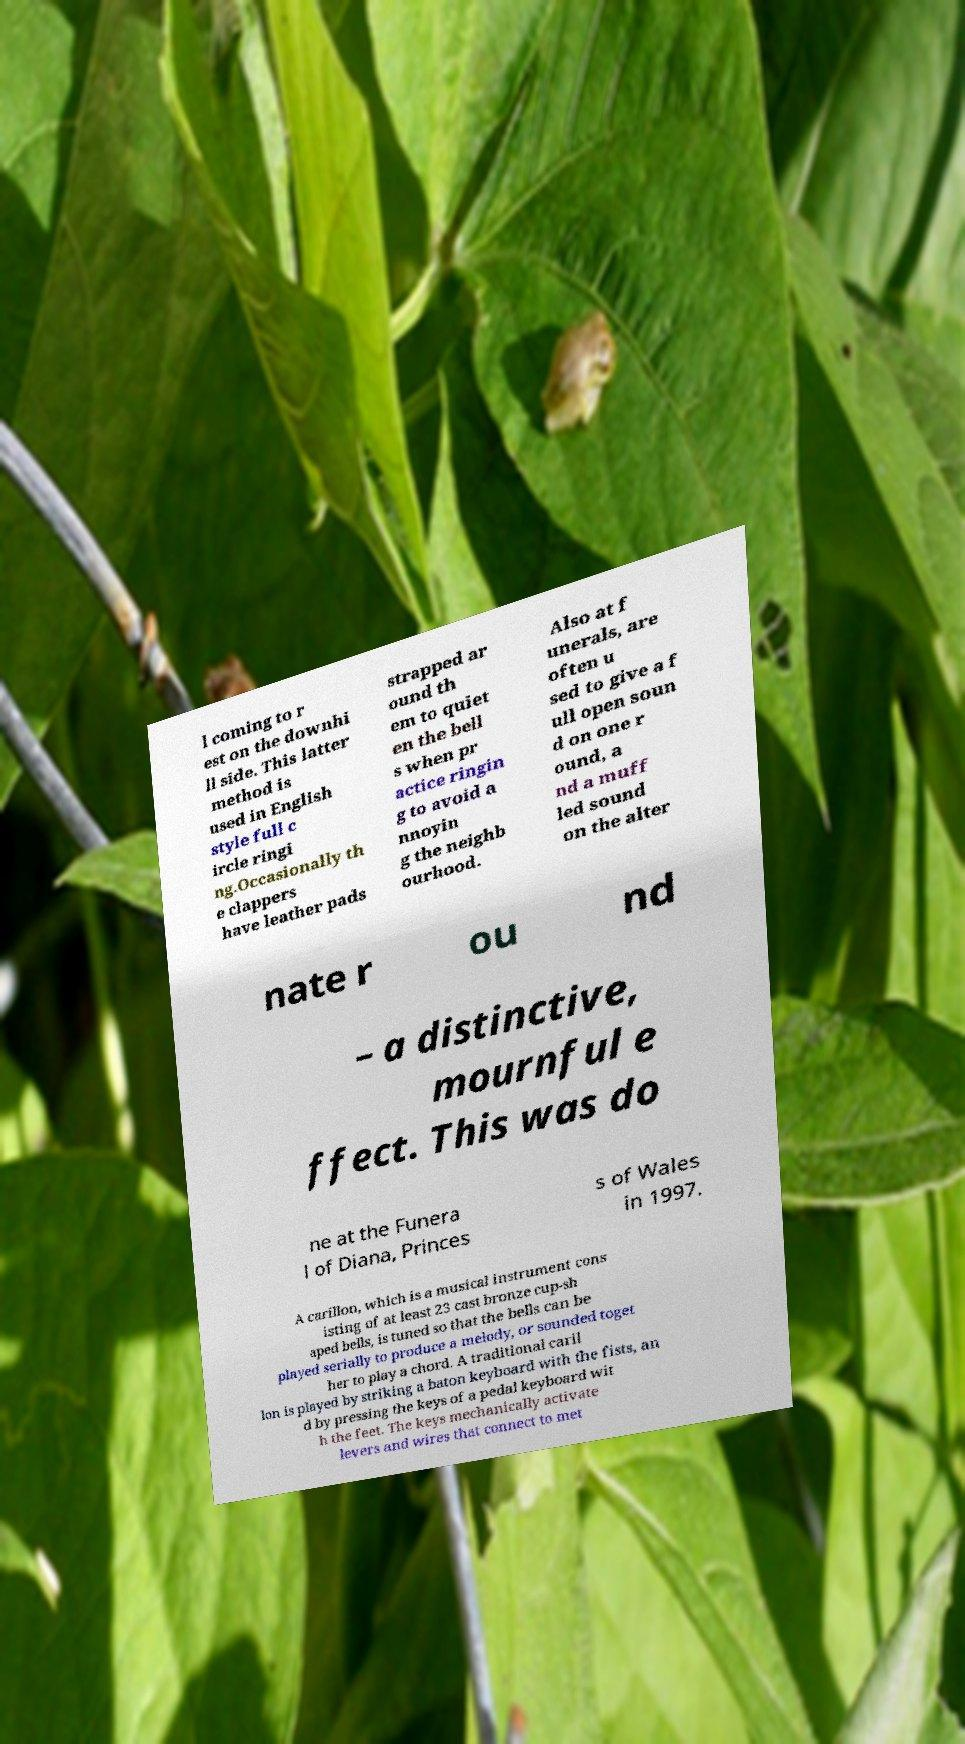Can you read and provide the text displayed in the image?This photo seems to have some interesting text. Can you extract and type it out for me? l coming to r est on the downhi ll side. This latter method is used in English style full c ircle ringi ng.Occasionally th e clappers have leather pads strapped ar ound th em to quiet en the bell s when pr actice ringin g to avoid a nnoyin g the neighb ourhood. Also at f unerals, are often u sed to give a f ull open soun d on one r ound, a nd a muff led sound on the alter nate r ou nd – a distinctive, mournful e ffect. This was do ne at the Funera l of Diana, Princes s of Wales in 1997. A carillon, which is a musical instrument cons isting of at least 23 cast bronze cup-sh aped bells, is tuned so that the bells can be played serially to produce a melody, or sounded toget her to play a chord. A traditional caril lon is played by striking a baton keyboard with the fists, an d by pressing the keys of a pedal keyboard wit h the feet. The keys mechanically activate levers and wires that connect to met 